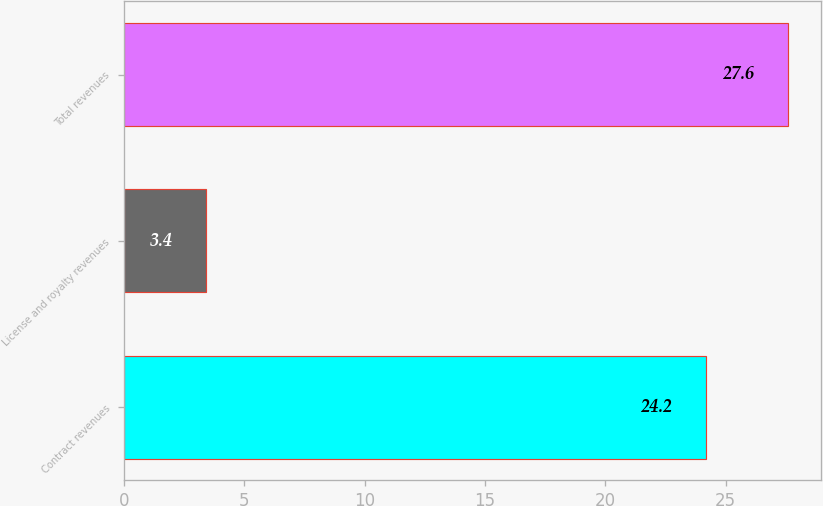<chart> <loc_0><loc_0><loc_500><loc_500><bar_chart><fcel>Contract revenues<fcel>License and royalty revenues<fcel>Total revenues<nl><fcel>24.2<fcel>3.4<fcel>27.6<nl></chart> 